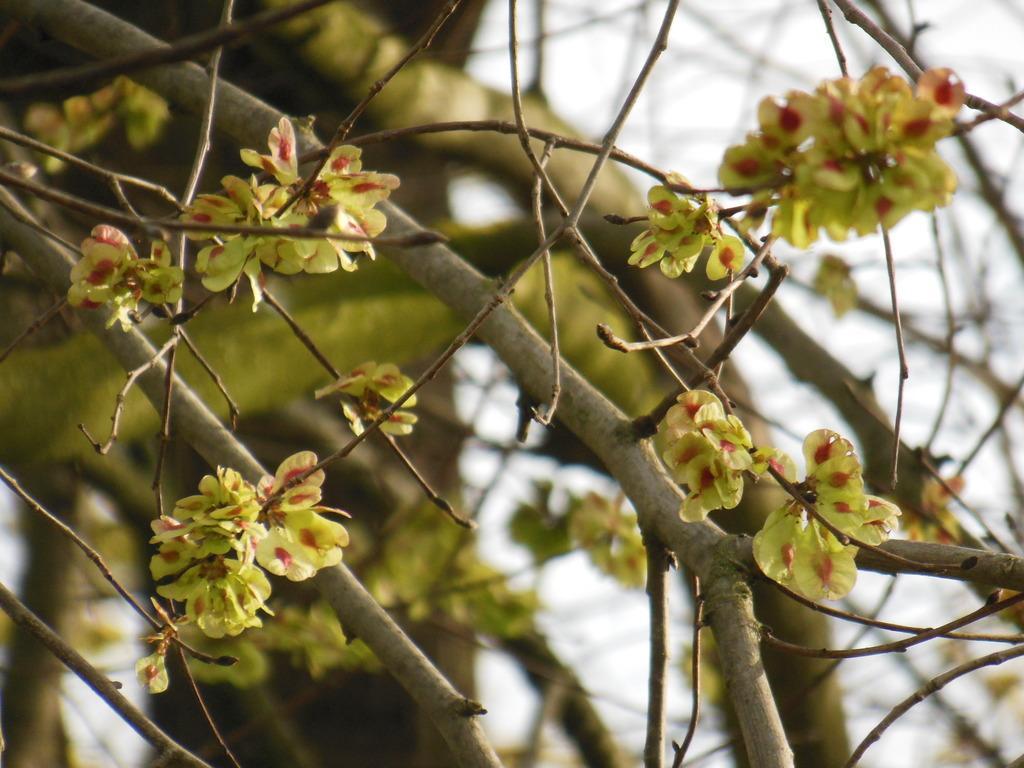How would you summarize this image in a sentence or two? In this image we can see the tree stems with flowers and buds. There is a white background, one object in the background looks like a tree, some dried tree stems and the background is blurred. 